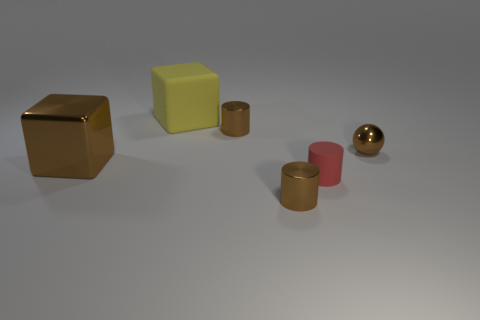Can you tell me what materials the objects in the image appear to be made from? Certainly! The objects in the image seem to be rendered to represent different materials. The cube on the left, along with the two cylinders in the center, appear to have a metallic finish, suggesting they might be made of metal. The yellow and red blocks look like they have a matte surface, possibly portraying materials like plastic or wood. 